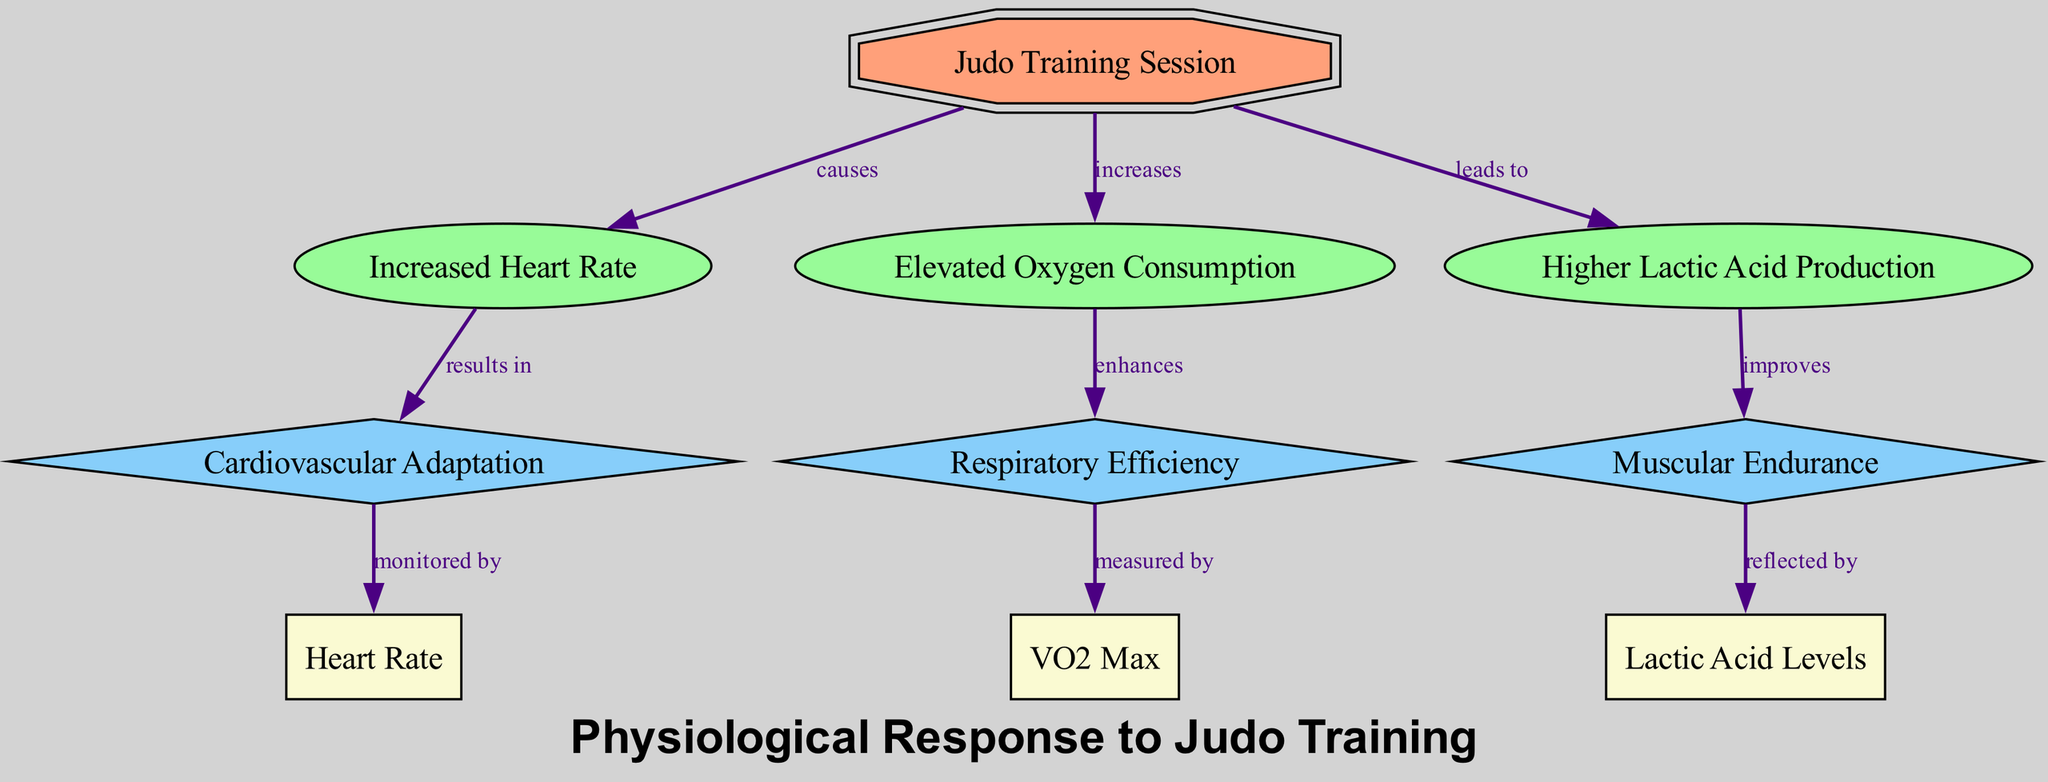What are the three main physiological responses to Judo training? The diagram lists "Increased Heart Rate," "Elevated Oxygen Consumption," and "Higher Lactic Acid Production" as the main physiological responses to Judo training.
Answer: Increased Heart Rate, Elevated Oxygen Consumption, Higher Lactic Acid Production How does increased heart rate affect cardiovascular adaptation? The diagram shows a directed edge from "Increased Heart Rate" to "Cardiovascular Adaptation" labeled "results in," indicating that an increase in heart rate leads to cardiovascular adaptation.
Answer: Cardiovascular Adaptation What type of node represents Judo Training Session? The "Judo Training Session" is displayed as an event node, which is denoted by its shape (double octagon) and fill color (light salmon).
Answer: event How many types of adaptations are displayed in the diagram? The diagram includes three adaptation nodes: "Cardiovascular Adaptation," "Respiratory Efficiency," and "Muscular Endurance," indicating a total of three types of adaptations from training.
Answer: 3 What do elevated oxygen consumption enhance? The flow from "Elevated Oxygen Consumption" to "Respiratory Efficiency" is clearly marked on the diagram with the label "enhances," revealing the relationship between these two nodes.
Answer: Respiratory Efficiency Which physiological response leads to higher lactic acid production? According to the diagram, "Higher Lactic Acid Production" is directly connected to "Increased Heart Rate" with the label "leads to," indicating that this response results from heart rate increase.
Answer: Increased Heart Rate What is VO2 Max measured by? The diagram illustrates that "VO2 Max" is measured by "Respiratory Efficiency," with a directed edge labeled "measured by."
Answer: Respiratory Efficiency How many nodes are connected to the "Judo Training Session"? The "Judo Training Session" node connects to three response nodes: "Increased Heart Rate," "Elevated Oxygen Consumption," and "Higher Lactic Acid Production," making the total connections three.
Answer: 3 What is reflected by higher lactic acid levels? The diagram indicates a connection from "Muscular Endurance" to "Lactic Acid Levels" with the label "reflected by," suggesting that changes in muscular endurance are observed through lactic acid levels.
Answer: Muscular Endurance 